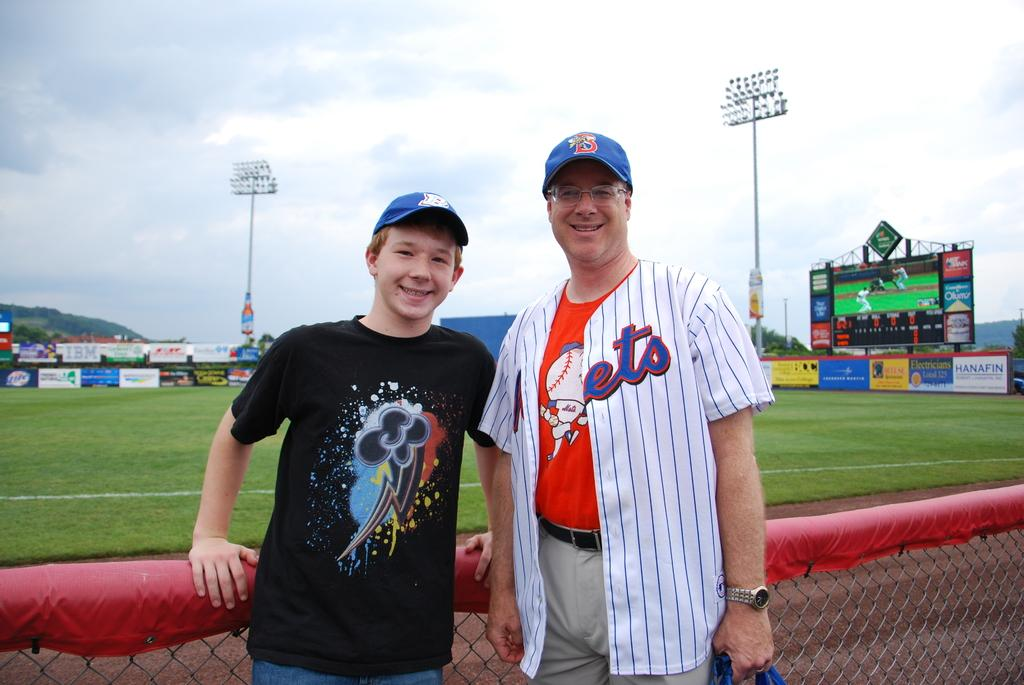<image>
Summarize the visual content of the image. a man has a hat on with the letter B on it 